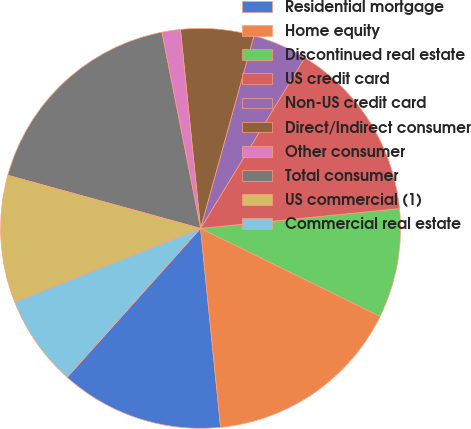Convert chart to OTSL. <chart><loc_0><loc_0><loc_500><loc_500><pie_chart><fcel>Residential mortgage<fcel>Home equity<fcel>Discontinued real estate<fcel>US credit card<fcel>Non-US credit card<fcel>Direct/Indirect consumer<fcel>Other consumer<fcel>Total consumer<fcel>US commercial (1)<fcel>Commercial real estate<nl><fcel>13.22%<fcel>16.15%<fcel>8.83%<fcel>14.69%<fcel>4.43%<fcel>5.9%<fcel>1.5%<fcel>17.62%<fcel>10.29%<fcel>7.36%<nl></chart> 